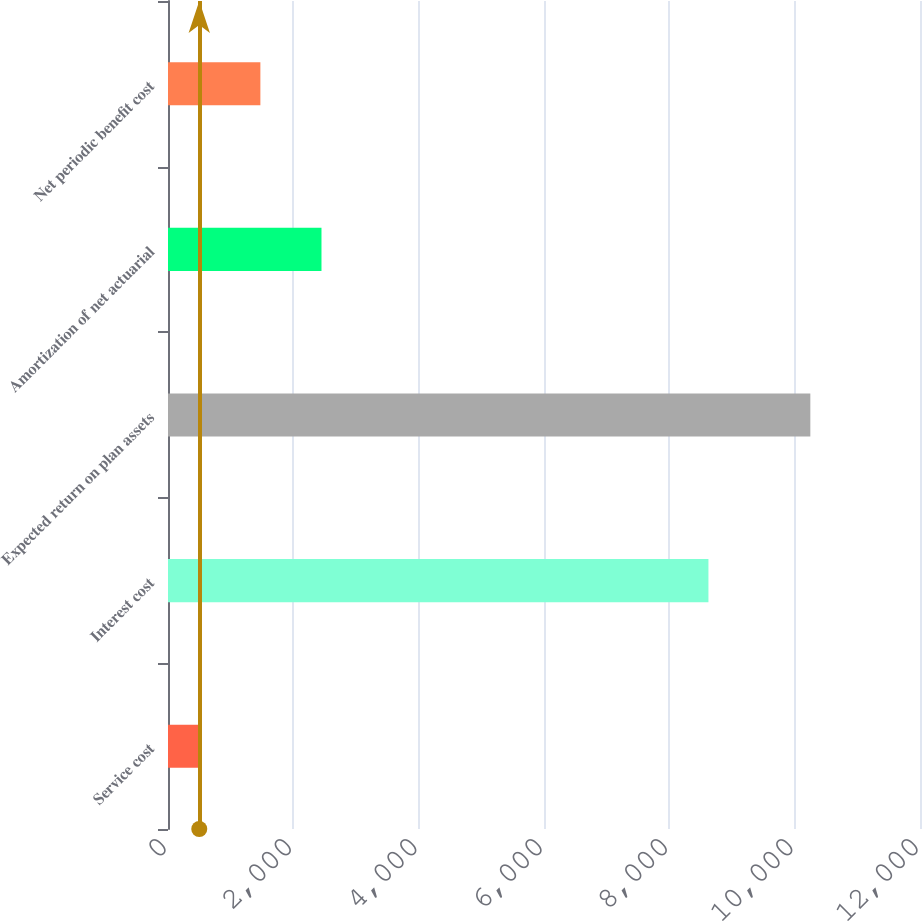Convert chart. <chart><loc_0><loc_0><loc_500><loc_500><bar_chart><fcel>Service cost<fcel>Interest cost<fcel>Expected return on plan assets<fcel>Amortization of net actuarial<fcel>Net periodic benefit cost<nl><fcel>499<fcel>8624<fcel>10250<fcel>2449.2<fcel>1474.1<nl></chart> 